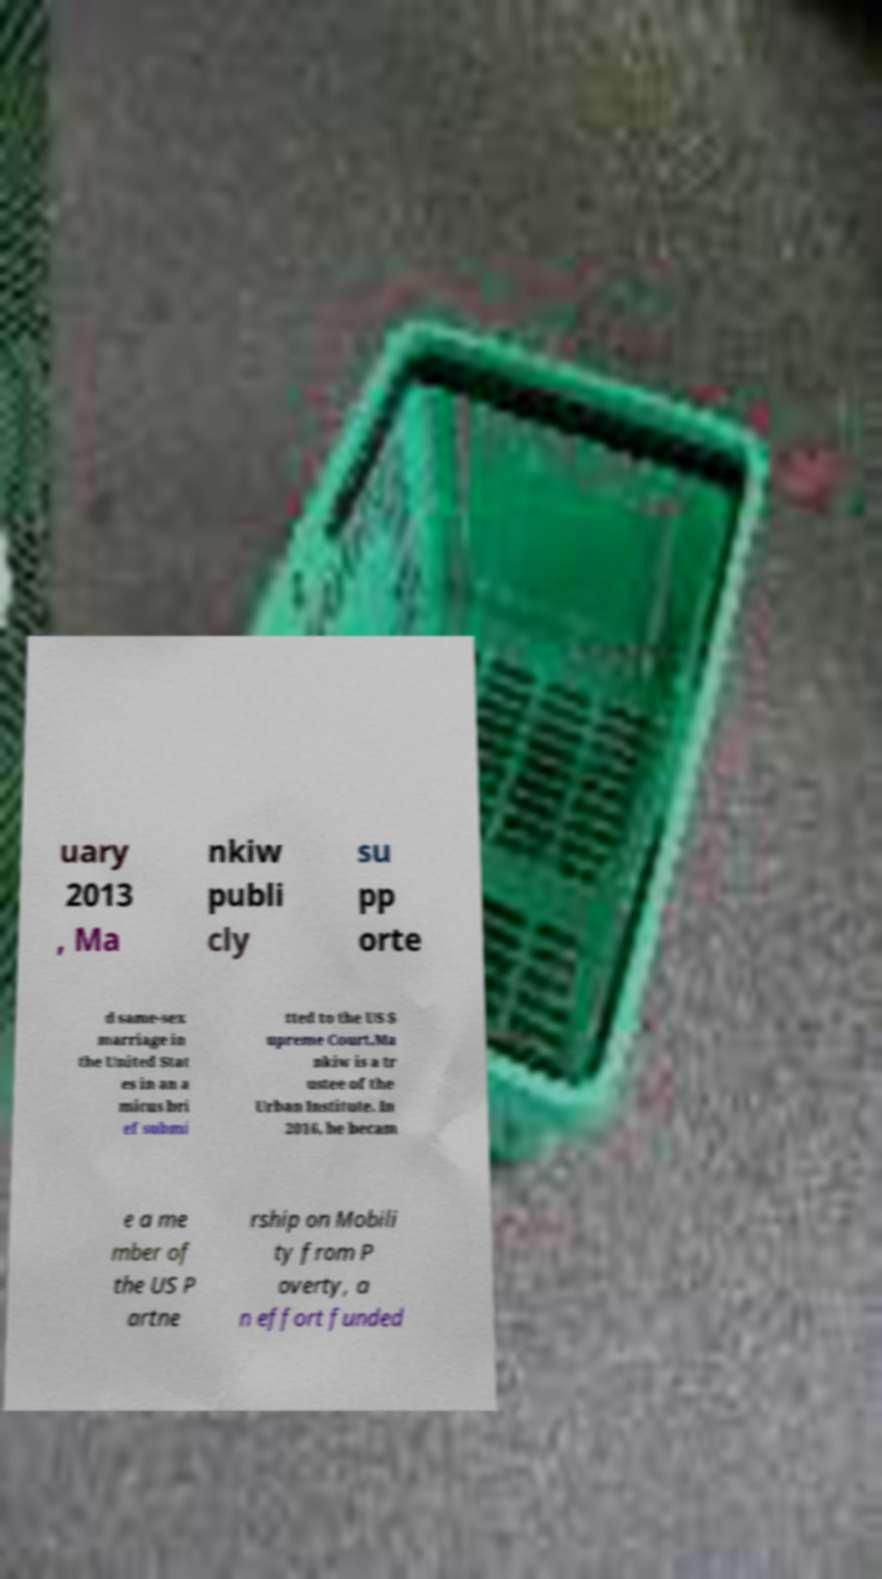Please read and relay the text visible in this image. What does it say? uary 2013 , Ma nkiw publi cly su pp orte d same-sex marriage in the United Stat es in an a micus bri ef submi tted to the US S upreme Court.Ma nkiw is a tr ustee of the Urban Institute. In 2016, he becam e a me mber of the US P artne rship on Mobili ty from P overty, a n effort funded 